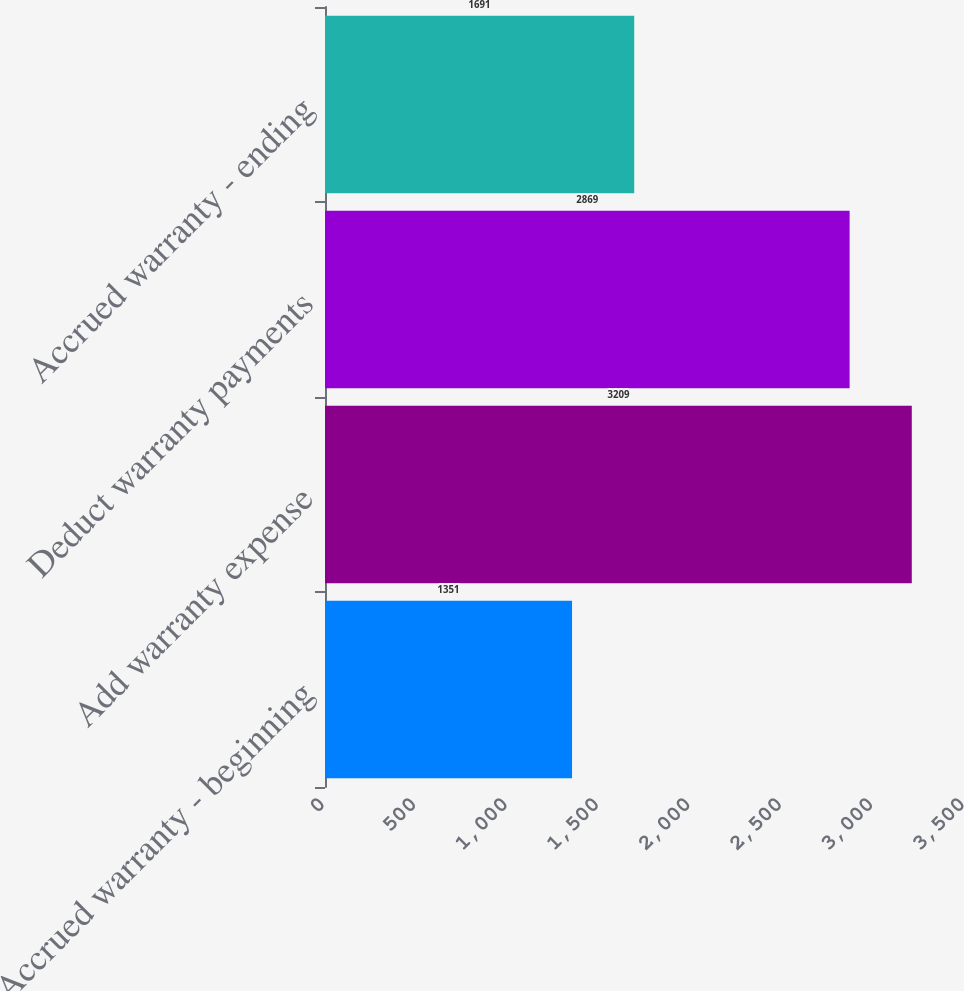Convert chart. <chart><loc_0><loc_0><loc_500><loc_500><bar_chart><fcel>Accrued warranty - beginning<fcel>Add warranty expense<fcel>Deduct warranty payments<fcel>Accrued warranty - ending<nl><fcel>1351<fcel>3209<fcel>2869<fcel>1691<nl></chart> 